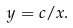<formula> <loc_0><loc_0><loc_500><loc_500>y = c / x .</formula> 